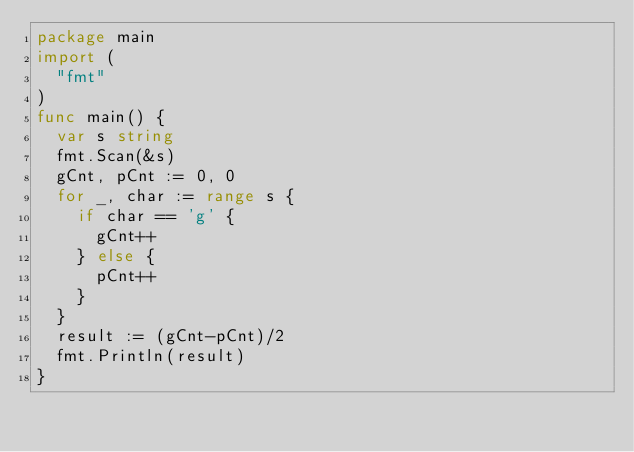<code> <loc_0><loc_0><loc_500><loc_500><_Go_>package main
import (
  "fmt"
)
func main() {
  var s string
  fmt.Scan(&s)
  gCnt, pCnt := 0, 0 
  for _, char := range s {
    if char == 'g' {
      gCnt++
    } else {
      pCnt++
    }
  }
  result := (gCnt-pCnt)/2
  fmt.Println(result)
}</code> 